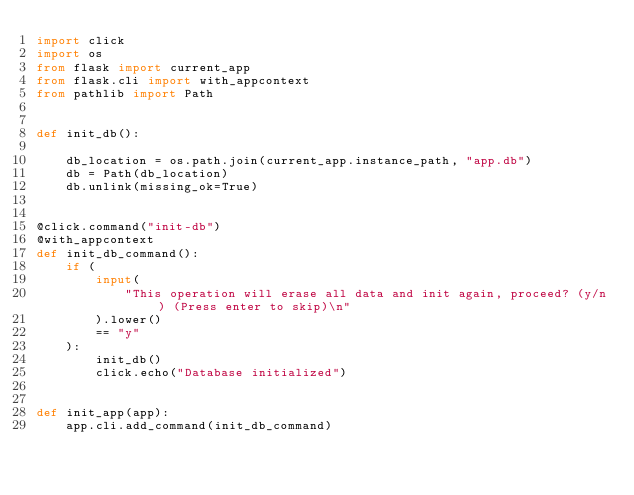Convert code to text. <code><loc_0><loc_0><loc_500><loc_500><_Python_>import click
import os
from flask import current_app
from flask.cli import with_appcontext
from pathlib import Path


def init_db():

    db_location = os.path.join(current_app.instance_path, "app.db")
    db = Path(db_location)
    db.unlink(missing_ok=True)


@click.command("init-db")
@with_appcontext
def init_db_command():
    if (
        input(
            "This operation will erase all data and init again, proceed? (y/n) (Press enter to skip)\n"
        ).lower()
        == "y"
    ):
        init_db()
        click.echo("Database initialized")


def init_app(app):
    app.cli.add_command(init_db_command)
</code> 